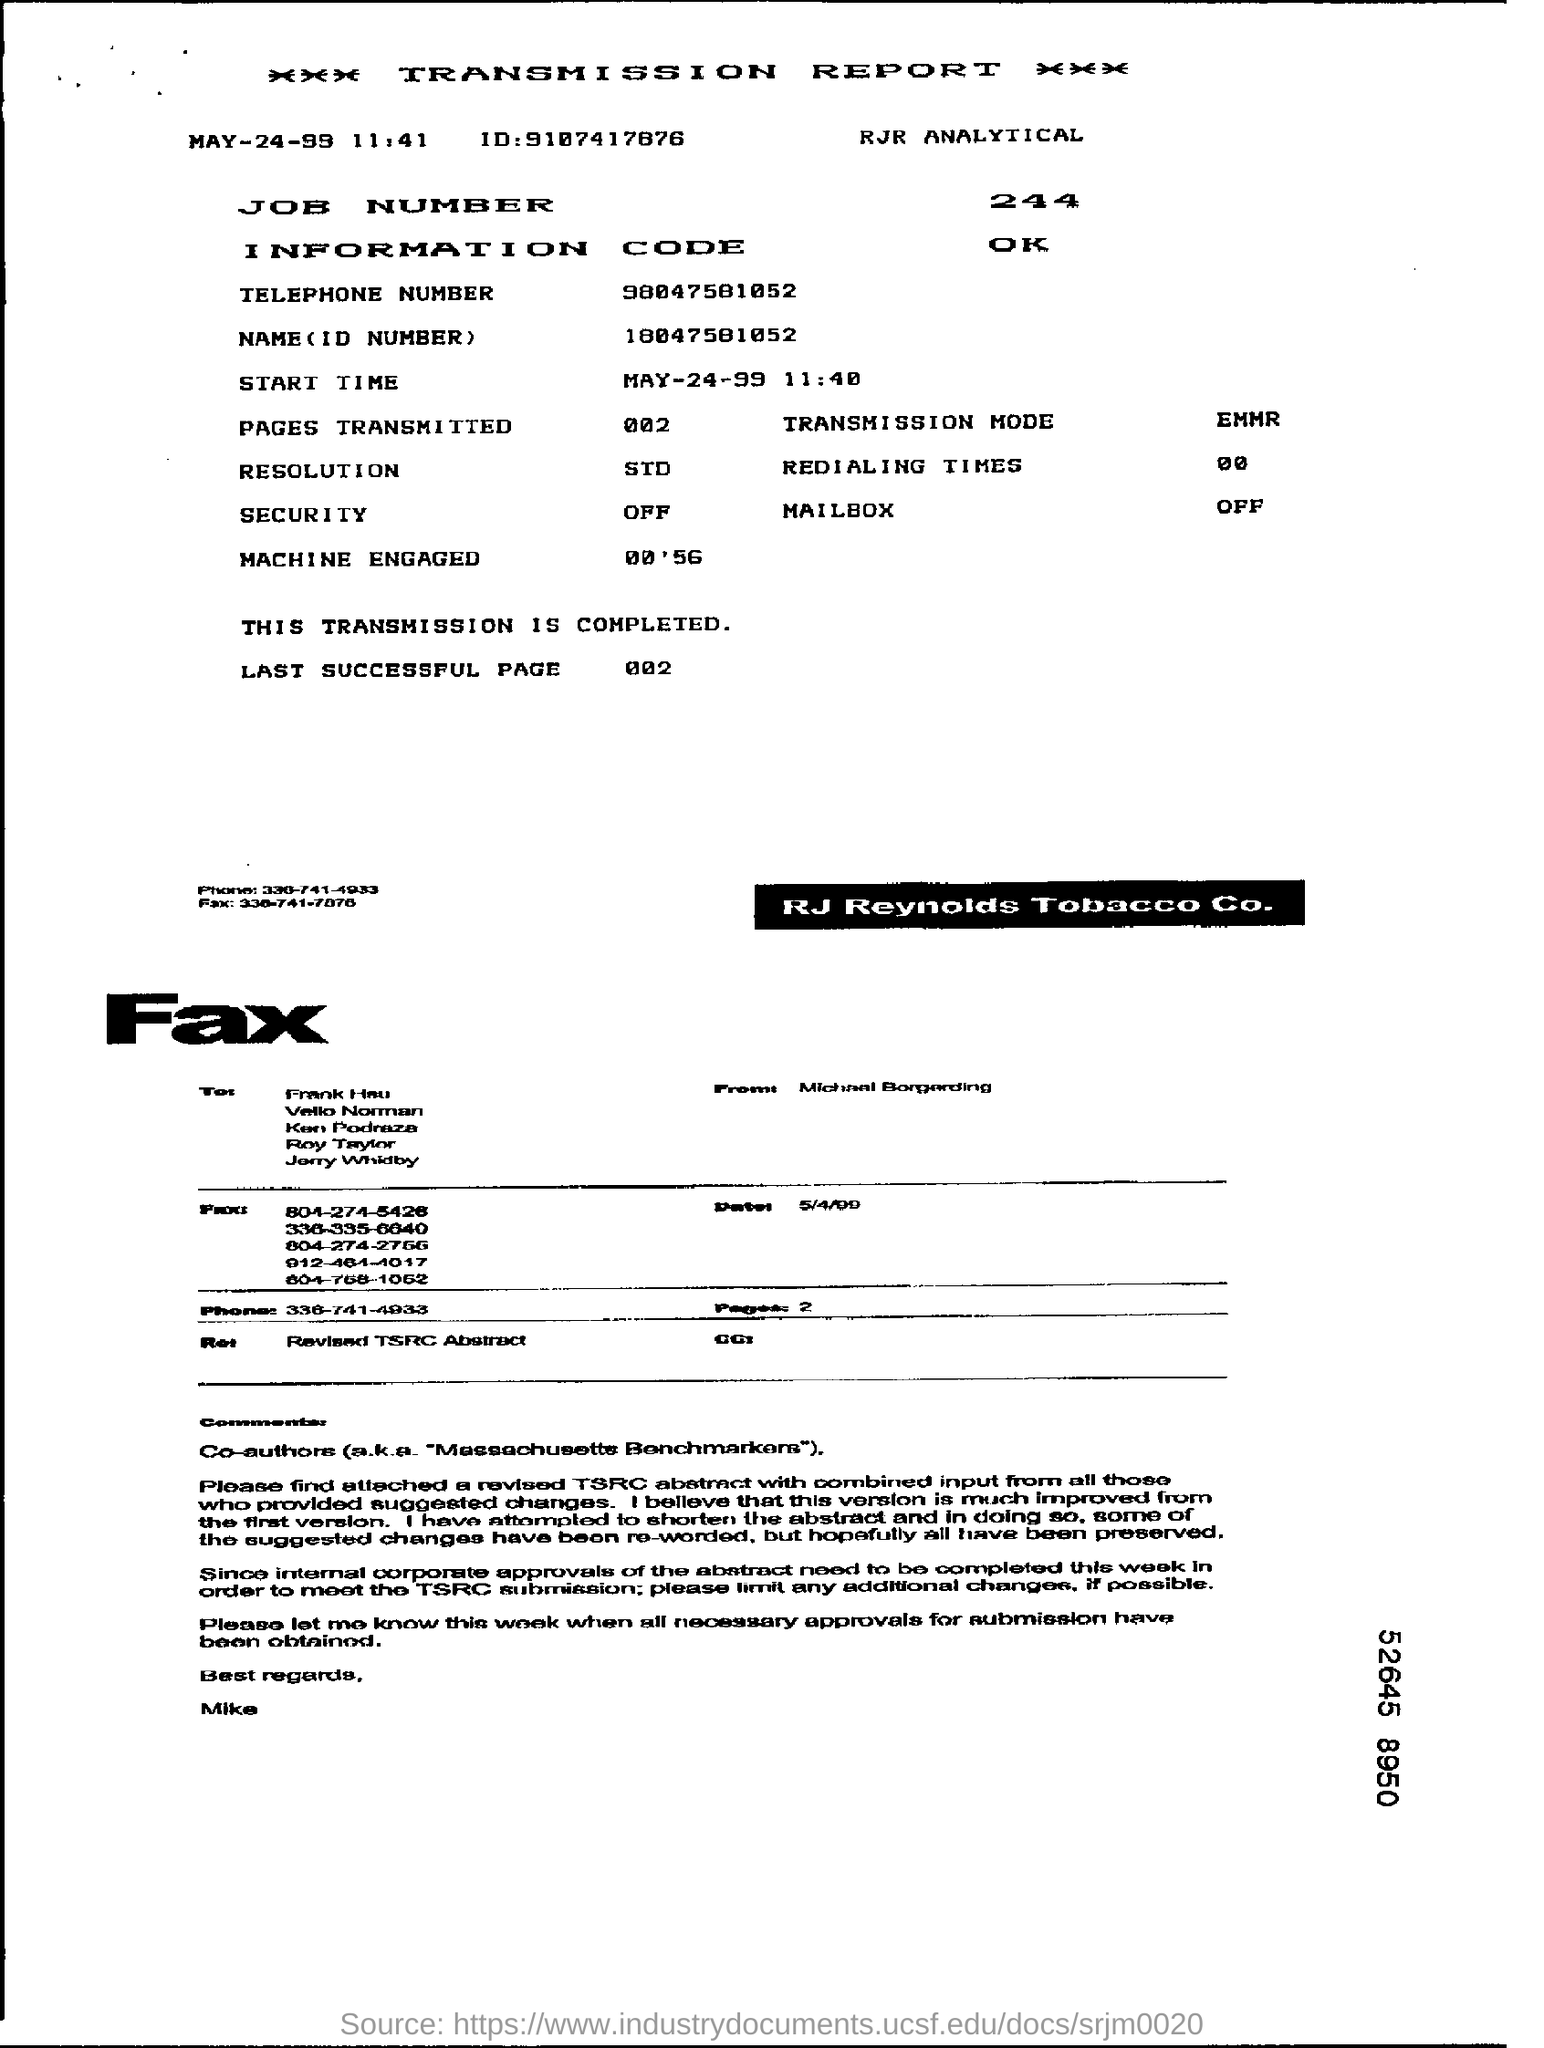List a handful of essential elements in this visual. This transmission report is giving information about a transmission. The start time of the transmission was MAY-24-99 at 11:40. What is the name and ID number given? 18047581052... The job number mentioned in the document is 244. The number of pages transmitted per document is zero. 